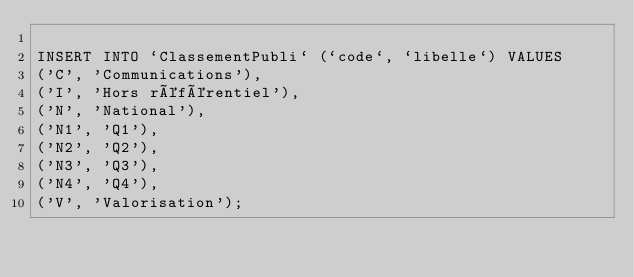Convert code to text. <code><loc_0><loc_0><loc_500><loc_500><_SQL_>
INSERT INTO `ClassementPubli` (`code`, `libelle`) VALUES
('C', 'Communications'),
('I', 'Hors référentiel'),
('N', 'National'),
('N1', 'Q1'),
('N2', 'Q2'),
('N3', 'Q3'),
('N4', 'Q4'),
('V', 'Valorisation');
</code> 